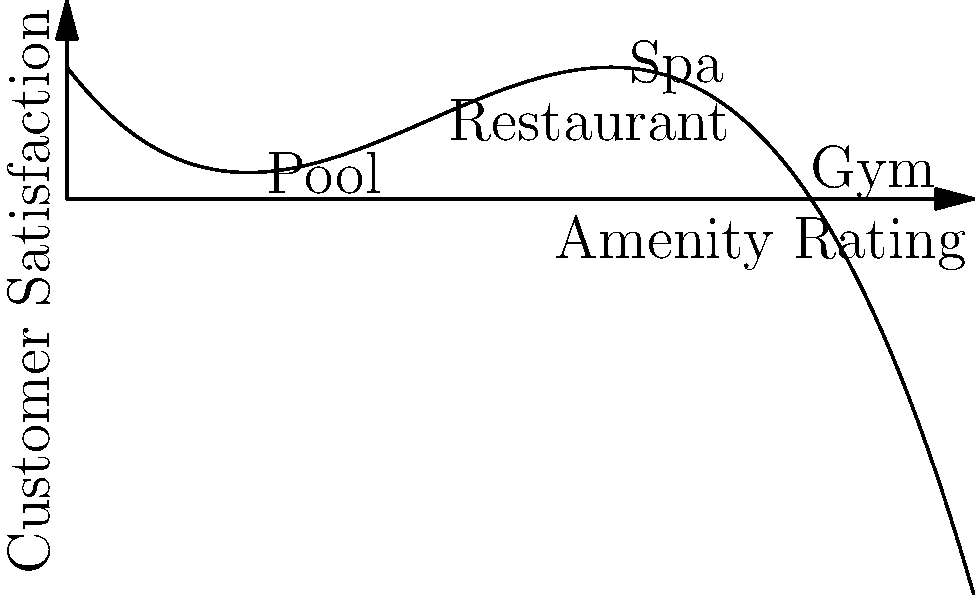A luxury resort conducted a survey to analyze customer satisfaction scores for different amenities. The results are represented by the polynomial function $f(x) = -0.5x^3 + 6x^2 - 18x + 20$, where $x$ is the amenity rating (0-10) and $f(x)$ is the customer satisfaction score. Based on the graph, which amenity has the highest customer satisfaction score, and what is that score (rounded to the nearest whole number)? To find the amenity with the highest customer satisfaction score, we need to:

1. Identify the x-coordinates (amenity ratings) for each amenity:
   Pool: x = 2
   Restaurant: x = 4
   Spa: x = 6
   Gym: x = 8

2. Calculate the y-coordinate (satisfaction score) for each amenity using $f(x) = -0.5x^3 + 6x^2 - 18x + 20$:

   Pool: $f(2) = -0.5(2^3) + 6(2^2) - 18(2) + 20 = -4 + 24 - 36 + 20 = 4$
   Restaurant: $f(4) = -0.5(4^3) + 6(4^2) - 18(4) + 20 = -32 + 96 - 72 + 20 = 12$
   Spa: $f(6) = -0.5(6^3) + 6(6^2) - 18(6) + 20 = -108 + 216 - 108 + 20 = 20$
   Gym: $f(8) = -0.5(8^3) + 6(8^2) - 18(8) + 20 = -256 + 384 - 144 + 20 = 4$

3. Compare the satisfaction scores:
   Pool: 4
   Restaurant: 12
   Spa: 20
   Gym: 4

The Spa has the highest satisfaction score at 20.
Answer: Spa, 20 